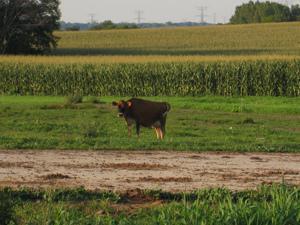How many cows are there?
Give a very brief answer. 1. 